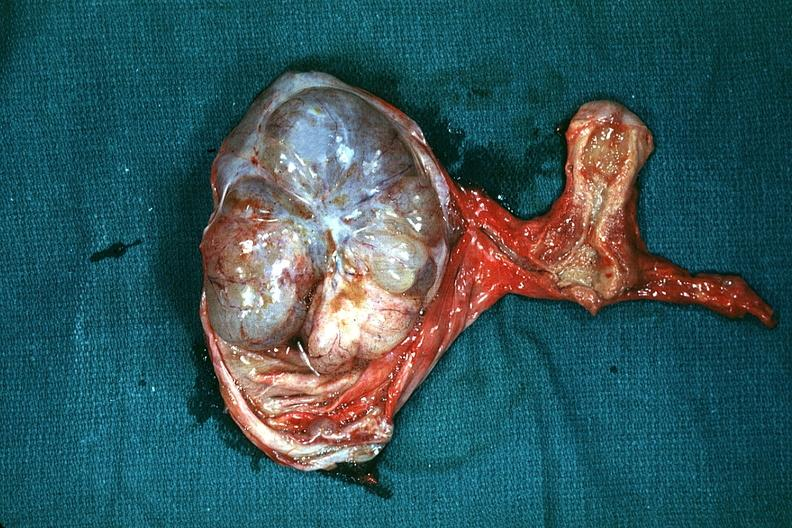what is present?
Answer the question using a single word or phrase. Ovary 